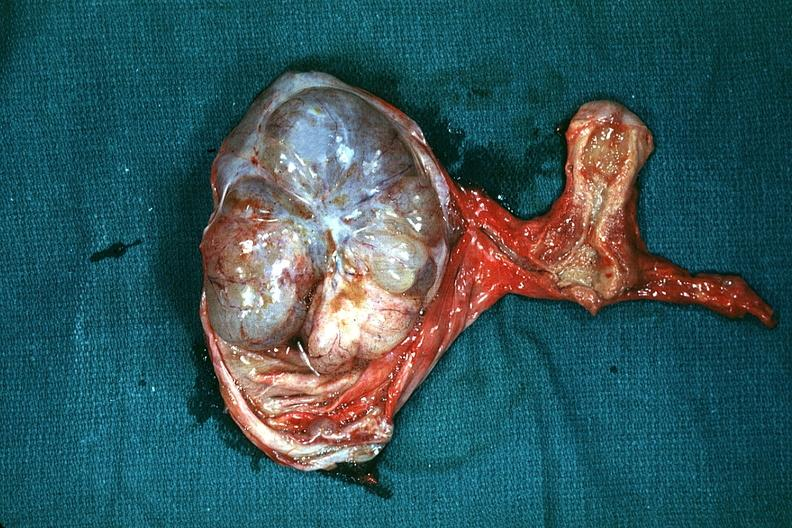what is present?
Answer the question using a single word or phrase. Ovary 